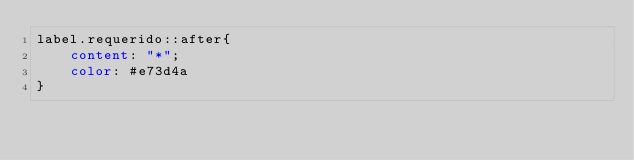Convert code to text. <code><loc_0><loc_0><loc_500><loc_500><_CSS_>label.requerido::after{
    content: "*";
    color: #e73d4a
}</code> 